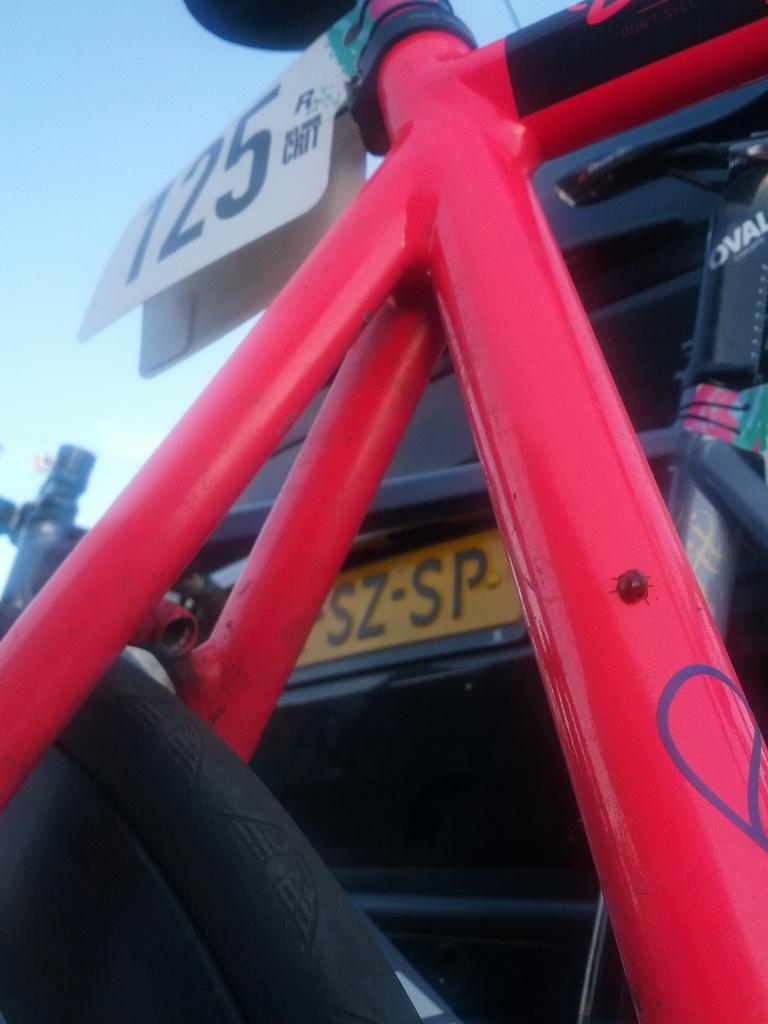How would you summarize this image in a sentence or two? In this image we can see a bicycle. In the background of the image there is a car with number plate. 